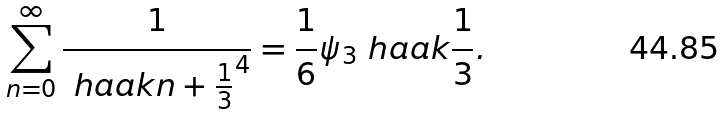Convert formula to latex. <formula><loc_0><loc_0><loc_500><loc_500>\sum _ { n = 0 } ^ { \infty } \frac { 1 } { \ h a a k { n + \frac { 1 } { 3 } } ^ { 4 } } = \frac { 1 } { 6 } \psi _ { 3 } \ h a a k { \frac { 1 } { 3 } } .</formula> 